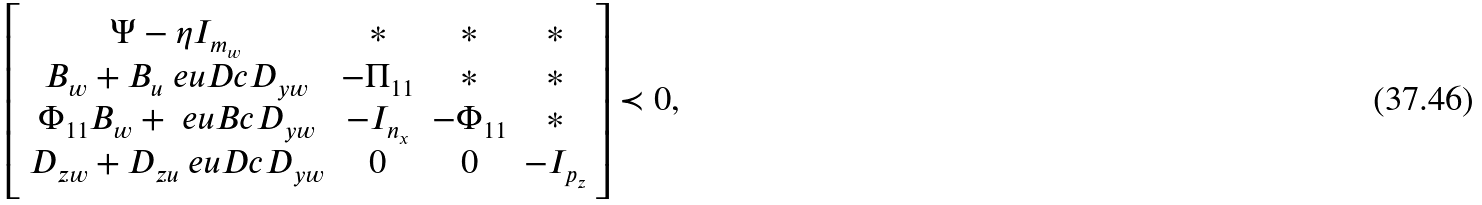<formula> <loc_0><loc_0><loc_500><loc_500>\left [ \begin{array} { c c c c } \Psi - \eta I _ { m _ { w } } & \ast & \ast & \ast \\ B _ { w } + B _ { u } \ e u D c D _ { y w } & - \Pi _ { 1 1 } & \ast & \ast \\ \Phi _ { 1 1 } B _ { w } + \ e u B c D _ { y w } & - I _ { n _ { x } } & - \Phi _ { 1 1 } & \ast \\ D _ { z w } + D _ { z u } \ e u D c D _ { y w } & 0 & 0 & - I _ { p _ { z } } \end{array} \right ] \prec 0 ,</formula> 